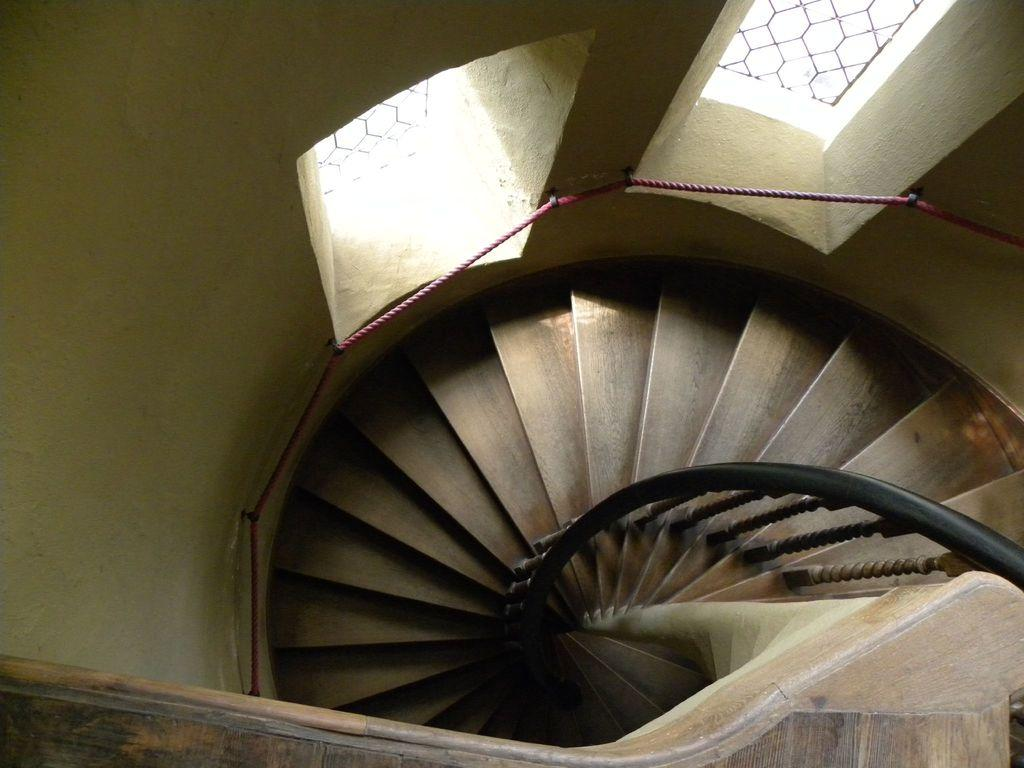What type of staircase is visible in the image? There is a spiral staircase in the image. Are there any other architectural features visible in the image? Yes, there are two windows on the wall in the image. How many boats can be seen sailing through the destruction in the image? There are no boats or destruction present in the image; it features a spiral staircase and two windows. Is there a doll visible in the image? There is no doll present in the image. 